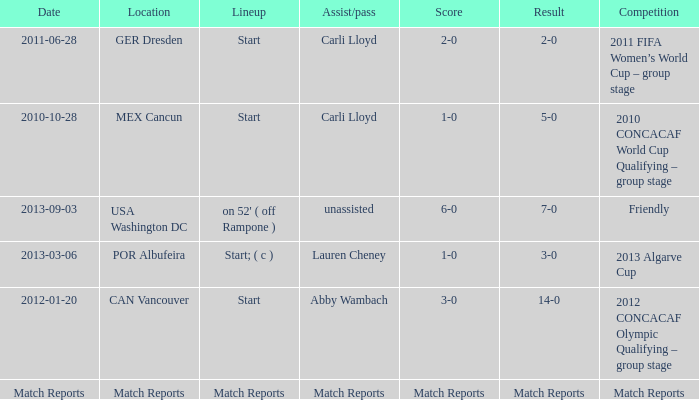Which score has a competition of match reports? Match Reports. 